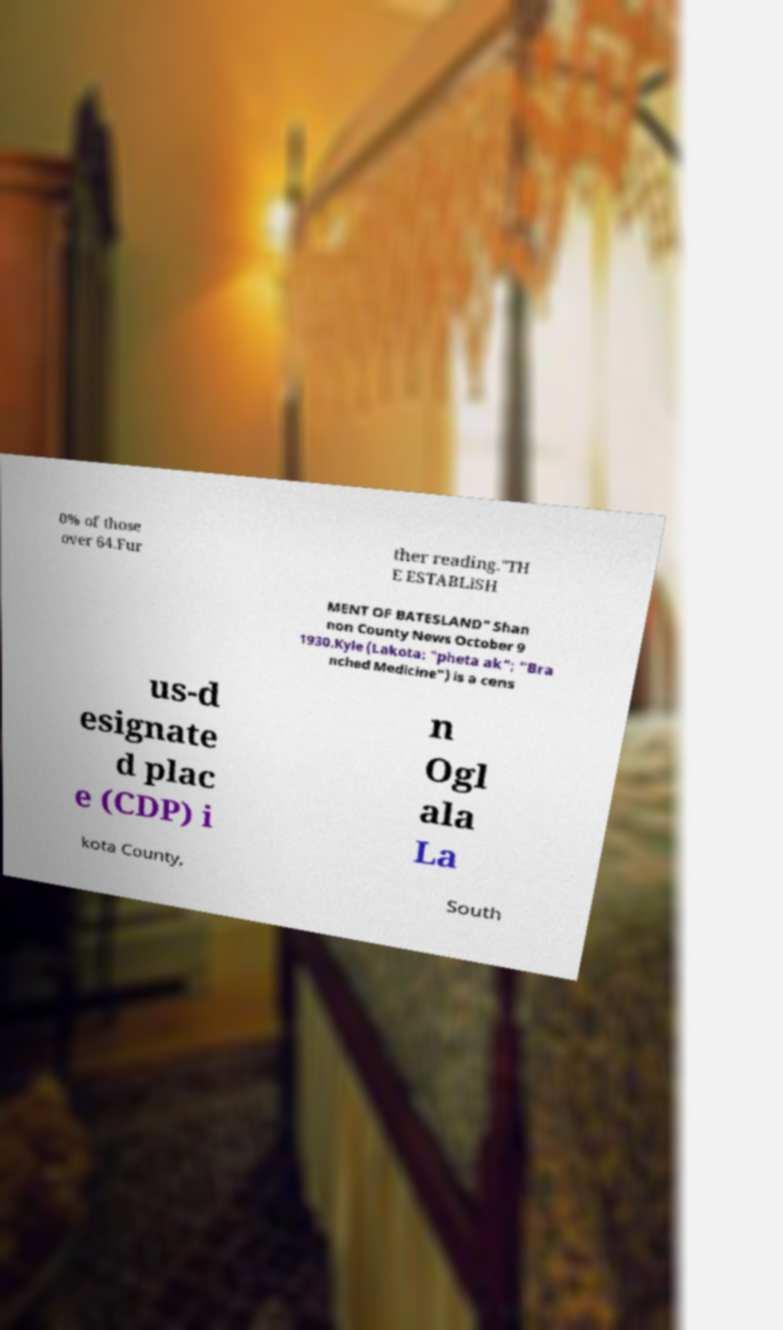I need the written content from this picture converted into text. Can you do that? 0% of those over 64.Fur ther reading."TH E ESTABLISH MENT OF BATESLAND" Shan non County News October 9 1930.Kyle (Lakota: "pheta ak"; "Bra nched Medicine") is a cens us-d esignate d plac e (CDP) i n Ogl ala La kota County, South 